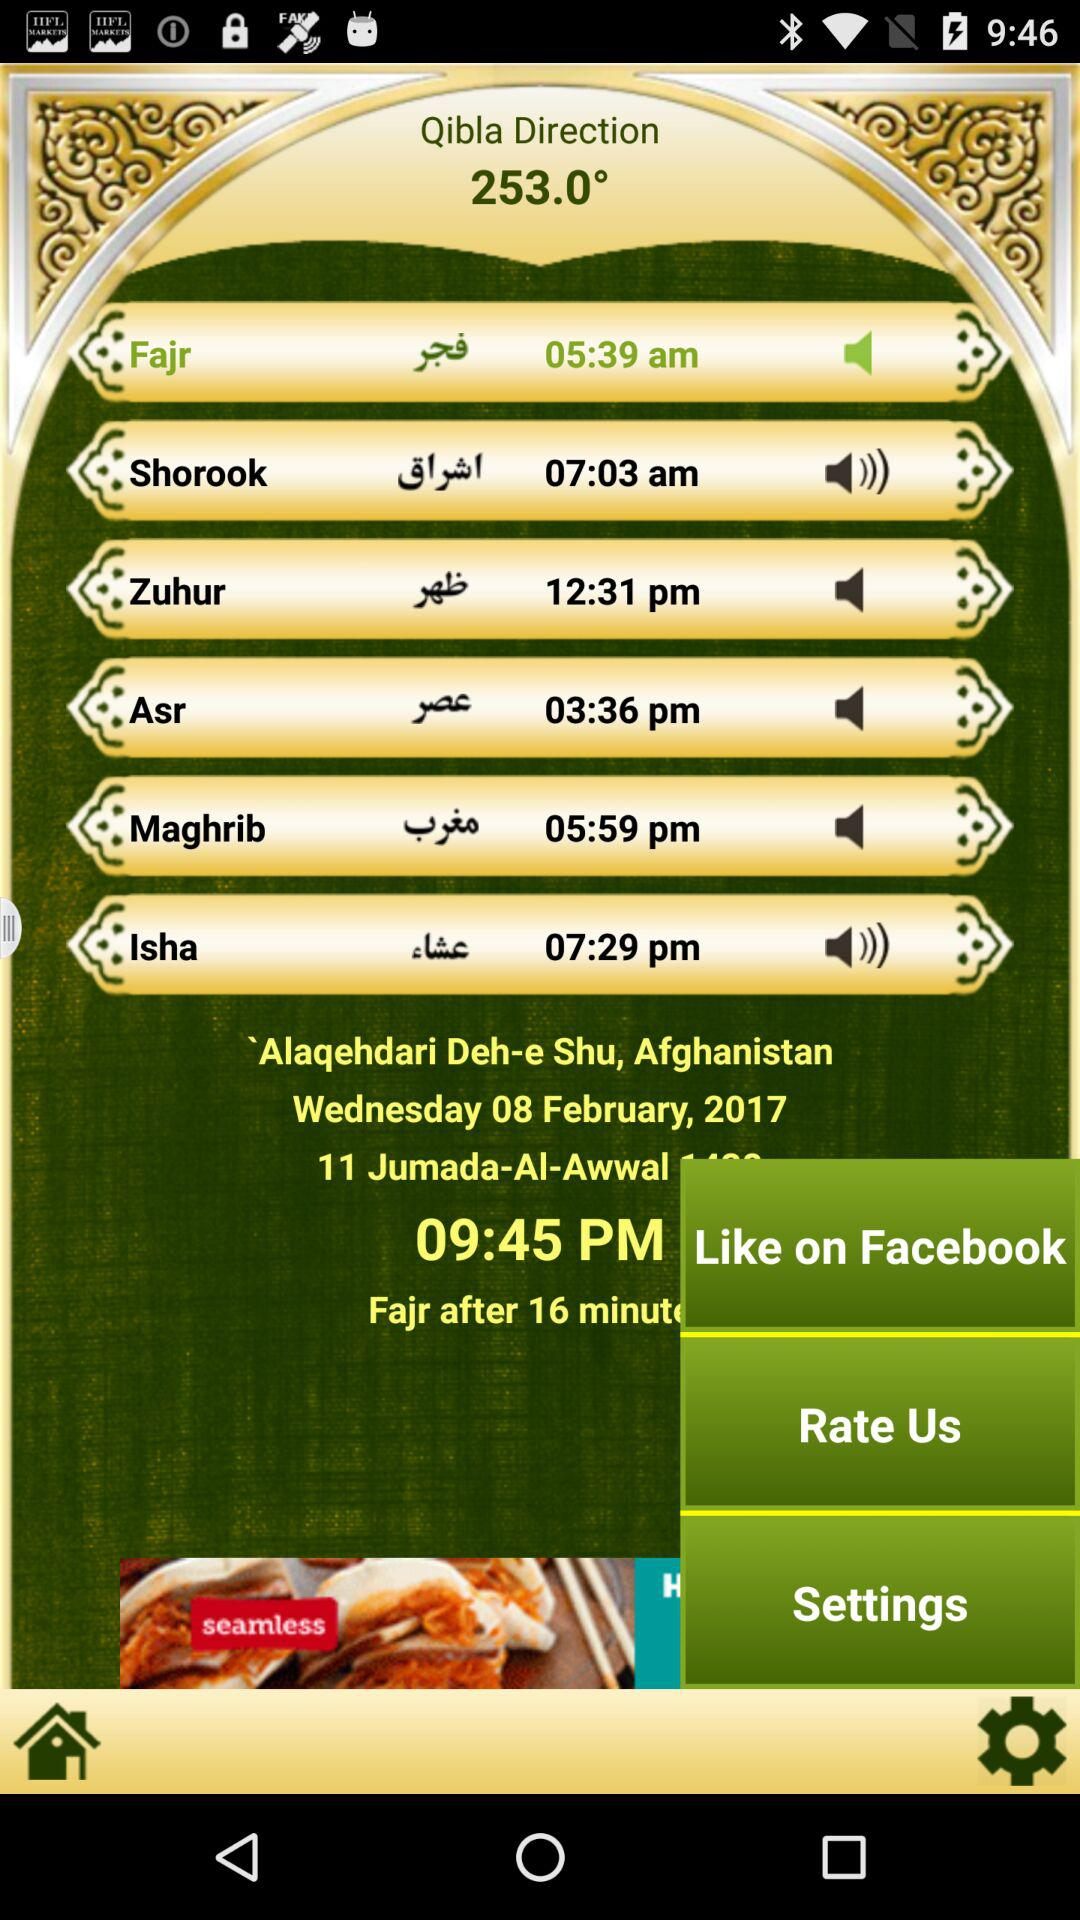How many more minutes until Fajr?
Answer the question using a single word or phrase. 16 minutes 